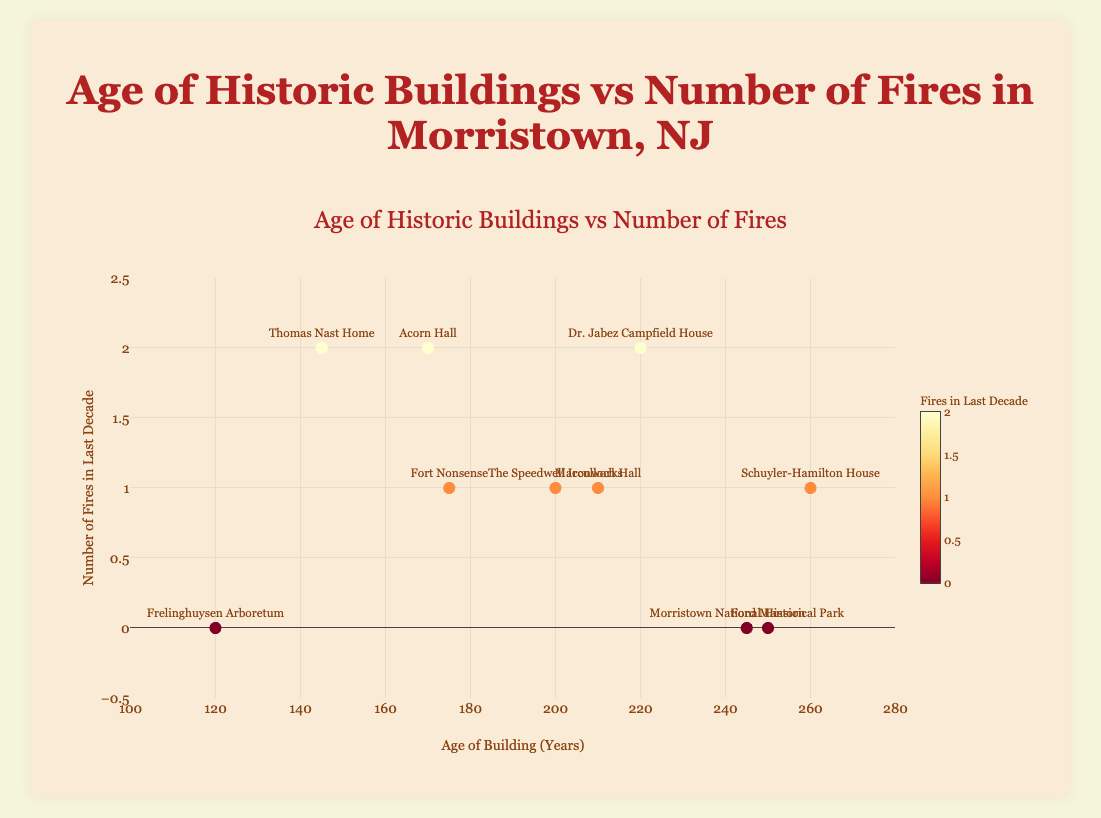How many historic buildings had no fires in the last decade? Locate all data points where the 'Number of Fires in Last Decade' value is 0. There are four buildings at this value.
Answer: 4 Which building is the oldest? Find the building with the maximum value on the 'Age of Building (Years)' axis. Schuyler-Hamilton House has an age of 260 years, making it the oldest.
Answer: Schuyler-Hamilton House Which building has experienced the highest number of fires in the last decade? Identify the building with the highest value on the 'Number of Fires in Last Decade' axis. Both Acorn Hall, Thomas Nast Home, and Dr. Jabez Campfield House have 2 fires each.
Answer: Acorn Hall, Thomas Nast Home, Dr. Jabez Campfield House Is there any relationship between the age of a building and the number of fires it has experienced in the last decade? Examine the scatter plot for any obvious trend between 'Age of Building (Years)' on the x-axis and 'Number of Fires in Last Decade' on the y-axis. The points are scattered without a definite trend, suggesting no clear relationship.
Answer: No clear relationship What is the average age of the historic buildings shown in the plot? Sum up the ages of all buildings and divide by the number of buildings. (250+170+260+210+120+245+145+175+220+200) / 10 = 1995 / 10 = 199.5
Answer: 199.5 Which buildings have an age in the range of 200 to 250 years? Look for buildings whose 'Age of Building (Years)' falls between 200 and 250 on the x-axis. The buildings are Ford Mansion, Macculloch Hall, Morristown National Historical Park, and The Speedwell Ironworks.
Answer: Ford Mansion, Macculloch Hall, Morristown National Historical Park, The Speedwell Ironworks How does the number of fires at Acorn Hall compare to that of Macculloch Hall? Check the 'Number of Fires in Last Decade' values for both buildings. Acorn Hall has 2 fires, while Macculloch Hall has 1 fire. Thus, Acorn Hall experienced more fires.
Answer: Acorn Hall has more fires What's the total number of fires reported across all historic buildings in the last decade? Sum up the 'Number of Fires in Last Decade' for all buildings. 0 + 2 + 1 + 1 + 0 + 0 + 2 + 1 + 2 + 1 = 10
Answer: 10 Which building is closest in age to the Thomas Nast Home? Determine the 'Age of Building (Years)' for the Thomas Nast Home (145 years) and identify the building whose age is nearest to this value. Next closest in age is Frelinghuysen Arboretum at 120 years.
Answer: Frelinghuysen Arboretum If a building is less than 150 years old, what's the probability that it had zero fires in the last decade? Determine the number of buildings less than 150 years old (which includes Frelinghuysen Arboretum and Thomas Nast Home). Only Frelinghuysen Arboretum had zero fires. There are 2 buildings, of which 1 had zero fires. Probability is 1/2 = 0.5 or 50%.
Answer: 50% 